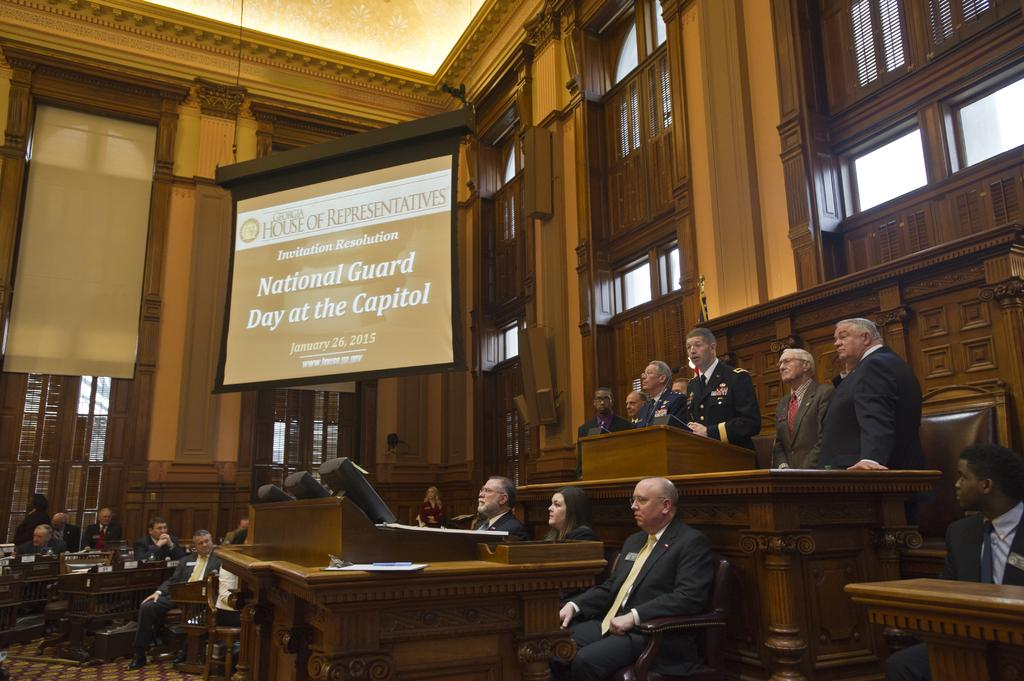How many people are present in the image? There are many people in the image. What are some of the people doing in the image? Some of the people are sitting, and some are standing. What can be seen on the screen in the image? The facts provided do not mention any details about the screen, so we cannot answer this question definitively. What type of servant is present in the image? There is no mention of a servant in the image. --- Facts: 1. There is a car in the image. 2. The car is red. 3. The car has four doors. 4. The car has a sunroof. Absurd Topics: unicorn, rainbow, umbrella Conversation: What is the main subject in the image? The main subject in the image is a car. Can you describe the car in the image? Yes, the car is red, has four doors, and a sunroof. What type of weather might be present in the image? The facts provided do not mention any details about the weather, so we cannot answer this question definitively. Reasoning: Let's think step by step in order to produce the conversation. We start by identifying the main subject of the image, which is a car. Next, we describe specific features of the car, such as its color, the number of doors, and the presence of a sunroof. Then, we address the type of weather that might be present in the image, but we cannot answer this question definitively, as the facts provided do not mention any details about the weather. Absurd Question/Answer: How many unicorns can be seen grazing in the image? There are no unicorns present in the image. --- Facts: 1. There is a group of people in the image. 2. The people are wearing hats. 3. The people are holding hands. 4. The people are standing in a circle. Absurd Topics: elephant, giraffe, gorilla Conversation: How many people are present in the image? The facts provided do not mention the exact number of people in the image, but we can see that there is a group of people in the image. Can you describe the attire of the people in the image? Yes, the people in the image are wearing hats. What are the people in the image doing? The people in the image are holding hands and standing in a circle. What type of animal can be seen in the image? There are no animals present in the image. Reasoning: Let's think step by step in order to produce the conversation. We start by acknowledging the presence of a group of people in the image. Next, we describe the attire of the people in the image, noting that they are wearing hats. Then, we observe the actions of the people in the image, noting that they are 